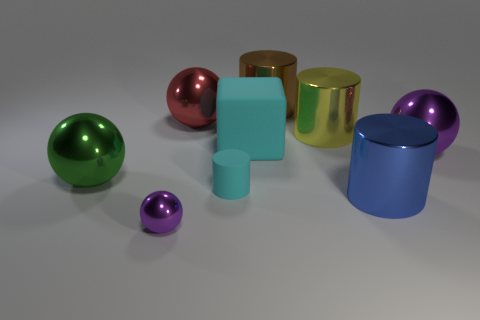Subtract all blue blocks. How many purple balls are left? 2 Subtract all cyan matte cylinders. How many cylinders are left? 3 Subtract all red spheres. How many spheres are left? 3 Subtract all red cylinders. Subtract all green blocks. How many cylinders are left? 4 Subtract all cylinders. How many objects are left? 5 Add 1 large brown metal cylinders. How many large brown metal cylinders are left? 2 Add 6 green balls. How many green balls exist? 7 Subtract 1 brown cylinders. How many objects are left? 8 Subtract all blue objects. Subtract all green spheres. How many objects are left? 7 